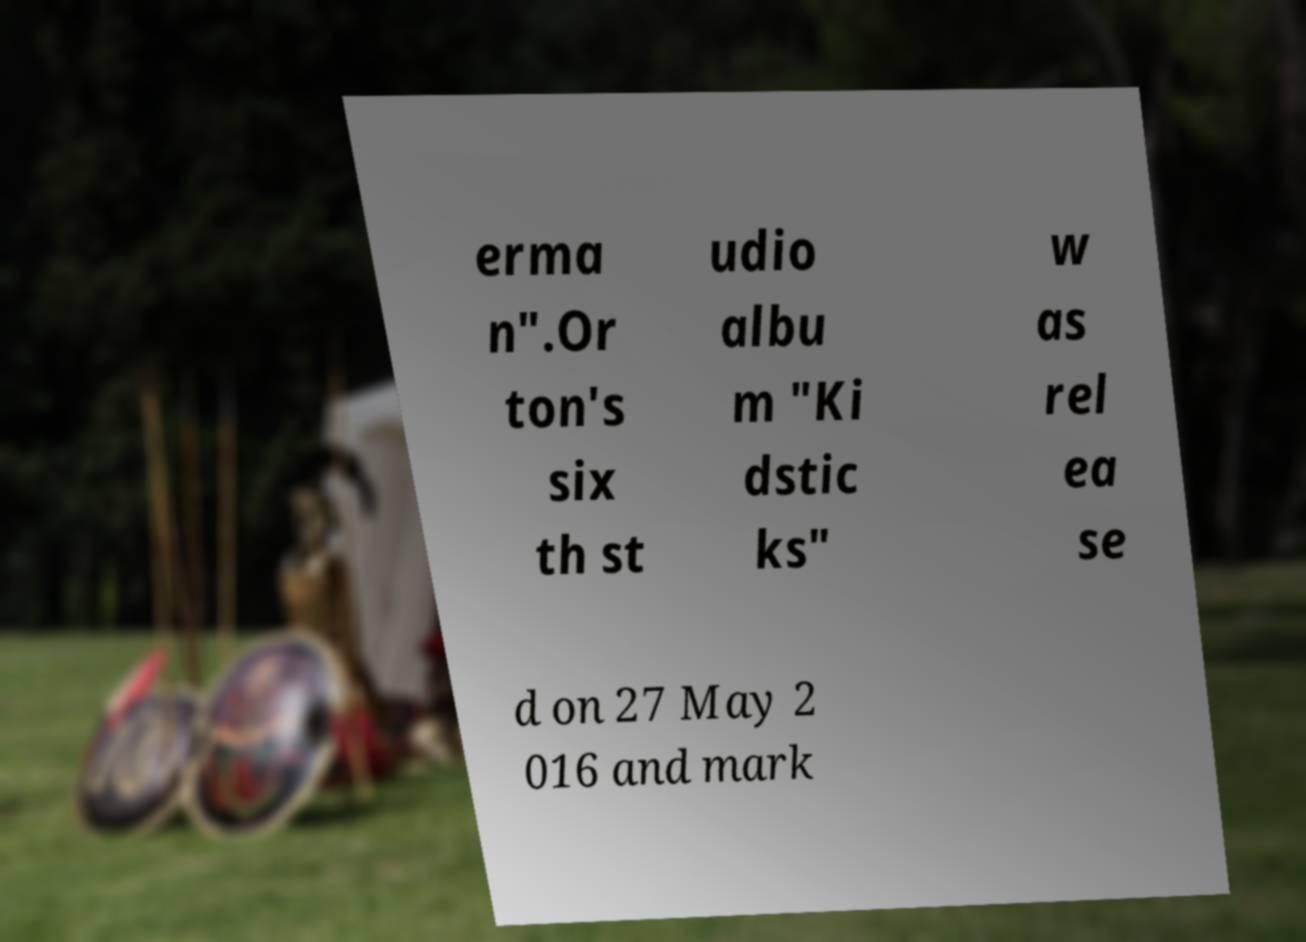Please identify and transcribe the text found in this image. erma n".Or ton's six th st udio albu m "Ki dstic ks" w as rel ea se d on 27 May 2 016 and mark 